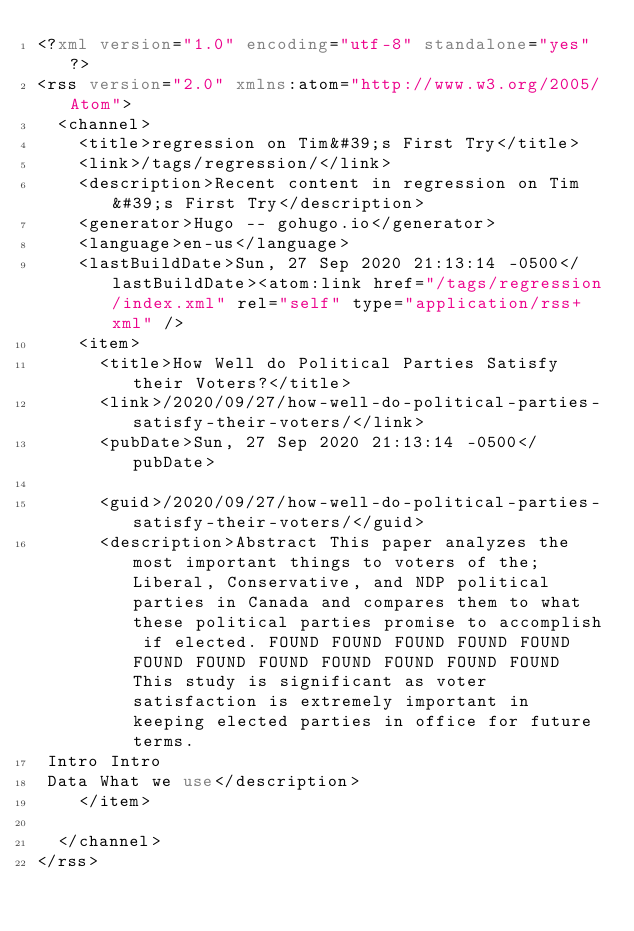Convert code to text. <code><loc_0><loc_0><loc_500><loc_500><_XML_><?xml version="1.0" encoding="utf-8" standalone="yes"?>
<rss version="2.0" xmlns:atom="http://www.w3.org/2005/Atom">
  <channel>
    <title>regression on Tim&#39;s First Try</title>
    <link>/tags/regression/</link>
    <description>Recent content in regression on Tim&#39;s First Try</description>
    <generator>Hugo -- gohugo.io</generator>
    <language>en-us</language>
    <lastBuildDate>Sun, 27 Sep 2020 21:13:14 -0500</lastBuildDate><atom:link href="/tags/regression/index.xml" rel="self" type="application/rss+xml" />
    <item>
      <title>How Well do Political Parties Satisfy their Voters?</title>
      <link>/2020/09/27/how-well-do-political-parties-satisfy-their-voters/</link>
      <pubDate>Sun, 27 Sep 2020 21:13:14 -0500</pubDate>
      
      <guid>/2020/09/27/how-well-do-political-parties-satisfy-their-voters/</guid>
      <description>Abstract This paper analyzes the most important things to voters of the; Liberal, Conservative, and NDP political parties in Canada and compares them to what these political parties promise to accomplish if elected. FOUND FOUND FOUND FOUND FOUND FOUND FOUND FOUND FOUND FOUND FOUND FOUND This study is significant as voter satisfaction is extremely important in keeping elected parties in office for future terms.
 Intro Intro
 Data What we use</description>
    </item>
    
  </channel>
</rss>
</code> 